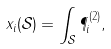<formula> <loc_0><loc_0><loc_500><loc_500>x _ { i } ( \mathcal { S } ) = \int _ { \mathcal { S } } \P _ { i } ^ { ( 2 ) } ,</formula> 